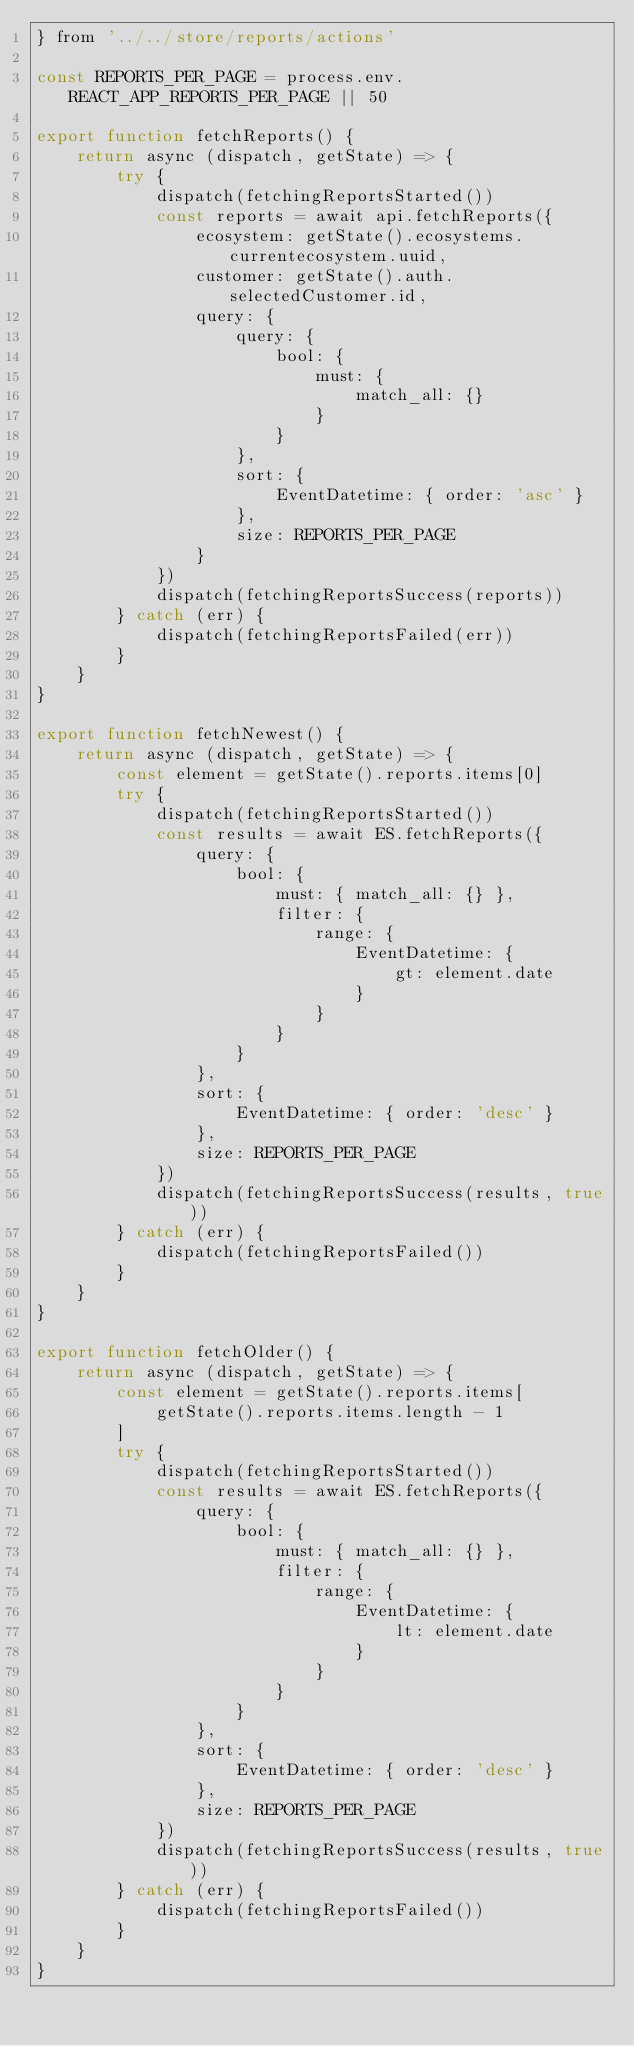Convert code to text. <code><loc_0><loc_0><loc_500><loc_500><_JavaScript_>} from '../../store/reports/actions'

const REPORTS_PER_PAGE = process.env.REACT_APP_REPORTS_PER_PAGE || 50

export function fetchReports() {
	return async (dispatch, getState) => {
		try {
			dispatch(fetchingReportsStarted())
			const reports = await api.fetchReports({
				ecosystem: getState().ecosystems.currentecosystem.uuid,
				customer: getState().auth.selectedCustomer.id,
				query: {
					query: {
						bool: {
							must: {
								match_all: {}
							}
						}
					},
					sort: {
						EventDatetime: { order: 'asc' }
					},
					size: REPORTS_PER_PAGE
				}
			})
			dispatch(fetchingReportsSuccess(reports))
		} catch (err) {
			dispatch(fetchingReportsFailed(err))
		}
	}
}

export function fetchNewest() {
	return async (dispatch, getState) => {
		const element = getState().reports.items[0]
		try {
			dispatch(fetchingReportsStarted())
			const results = await ES.fetchReports({
				query: {
					bool: {
						must: { match_all: {} },
						filter: {
							range: {
								EventDatetime: {
									gt: element.date
								}
							}
						}
					}
				},
				sort: {
					EventDatetime: { order: 'desc' }
				},
				size: REPORTS_PER_PAGE
			})
			dispatch(fetchingReportsSuccess(results, true))
		} catch (err) {
			dispatch(fetchingReportsFailed())
		}
	}
}

export function fetchOlder() {
	return async (dispatch, getState) => {
		const element = getState().reports.items[
			getState().reports.items.length - 1
		]
		try {
			dispatch(fetchingReportsStarted())
			const results = await ES.fetchReports({
				query: {
					bool: {
						must: { match_all: {} },
						filter: {
							range: {
								EventDatetime: {
									lt: element.date
								}
							}
						}
					}
				},
				sort: {
					EventDatetime: { order: 'desc' }
				},
				size: REPORTS_PER_PAGE
			})
			dispatch(fetchingReportsSuccess(results, true))
		} catch (err) {
			dispatch(fetchingReportsFailed())
		}
	}
}
</code> 